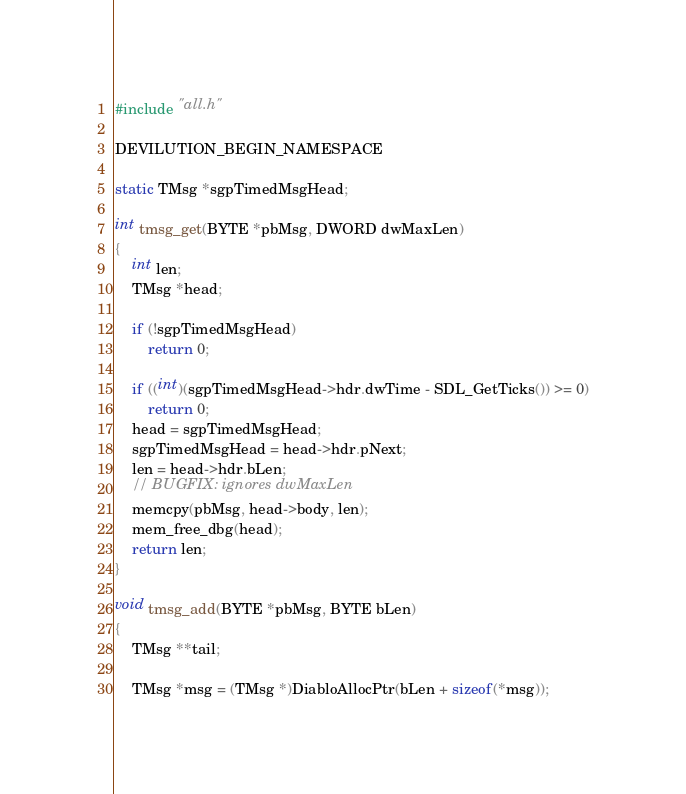Convert code to text. <code><loc_0><loc_0><loc_500><loc_500><_C++_>#include "all.h"

DEVILUTION_BEGIN_NAMESPACE

static TMsg *sgpTimedMsgHead;

int tmsg_get(BYTE *pbMsg, DWORD dwMaxLen)
{
	int len;
	TMsg *head;

	if (!sgpTimedMsgHead)
		return 0;

	if ((int)(sgpTimedMsgHead->hdr.dwTime - SDL_GetTicks()) >= 0)
		return 0;
	head = sgpTimedMsgHead;
	sgpTimedMsgHead = head->hdr.pNext;
	len = head->hdr.bLen;
	// BUGFIX: ignores dwMaxLen
	memcpy(pbMsg, head->body, len);
	mem_free_dbg(head);
	return len;
}

void tmsg_add(BYTE *pbMsg, BYTE bLen)
{
	TMsg **tail;

	TMsg *msg = (TMsg *)DiabloAllocPtr(bLen + sizeof(*msg));</code> 